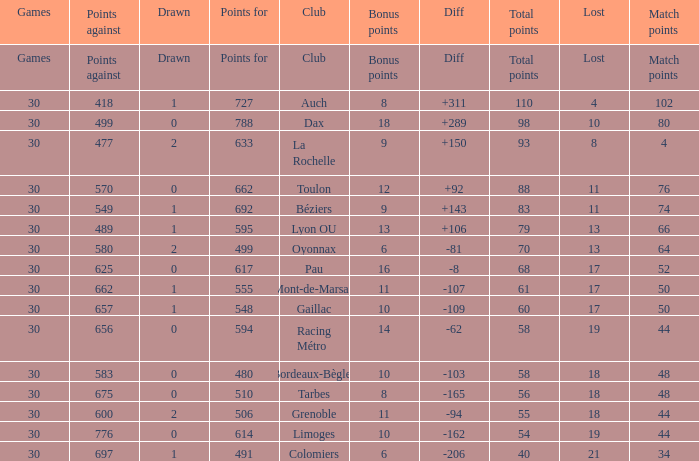What is the value of match points when the points for is 570? 76.0. 